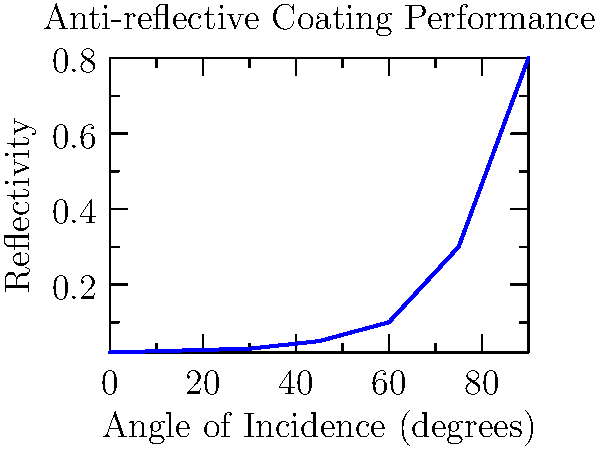Based on the graph showing the angle-dependent reflectivity of an anti-reflective coating on a solar cell, at what angle of incidence does the reflectivity first exceed 10%? To determine at which angle of incidence the reflectivity first exceeds 10%, we need to analyze the graph step-by-step:

1. The x-axis represents the angle of incidence in degrees, while the y-axis shows the reflectivity.
2. We need to find the point where the curve crosses the 0.1 (10%) reflectivity line.
3. Examining the graph from left to right:
   - At 0°, the reflectivity is about 0.02 (2%)
   - At 15°, it's slightly higher, around 0.025 (2.5%)
   - At 30°, it's about 0.03 (3%)
   - At 45°, it increases to about 0.05 (5%)
   - At 60°, it reaches 0.1 (10%)
   - Beyond 60°, it exceeds 10%
4. Therefore, the reflectivity first exceeds 10% just after 60° angle of incidence.

This behavior is consistent with the physics of anti-reflective coatings, which are typically designed to minimize reflections at normal incidence but become less effective at larger angles due to the change in optical path length through the coating.
Answer: 60° 